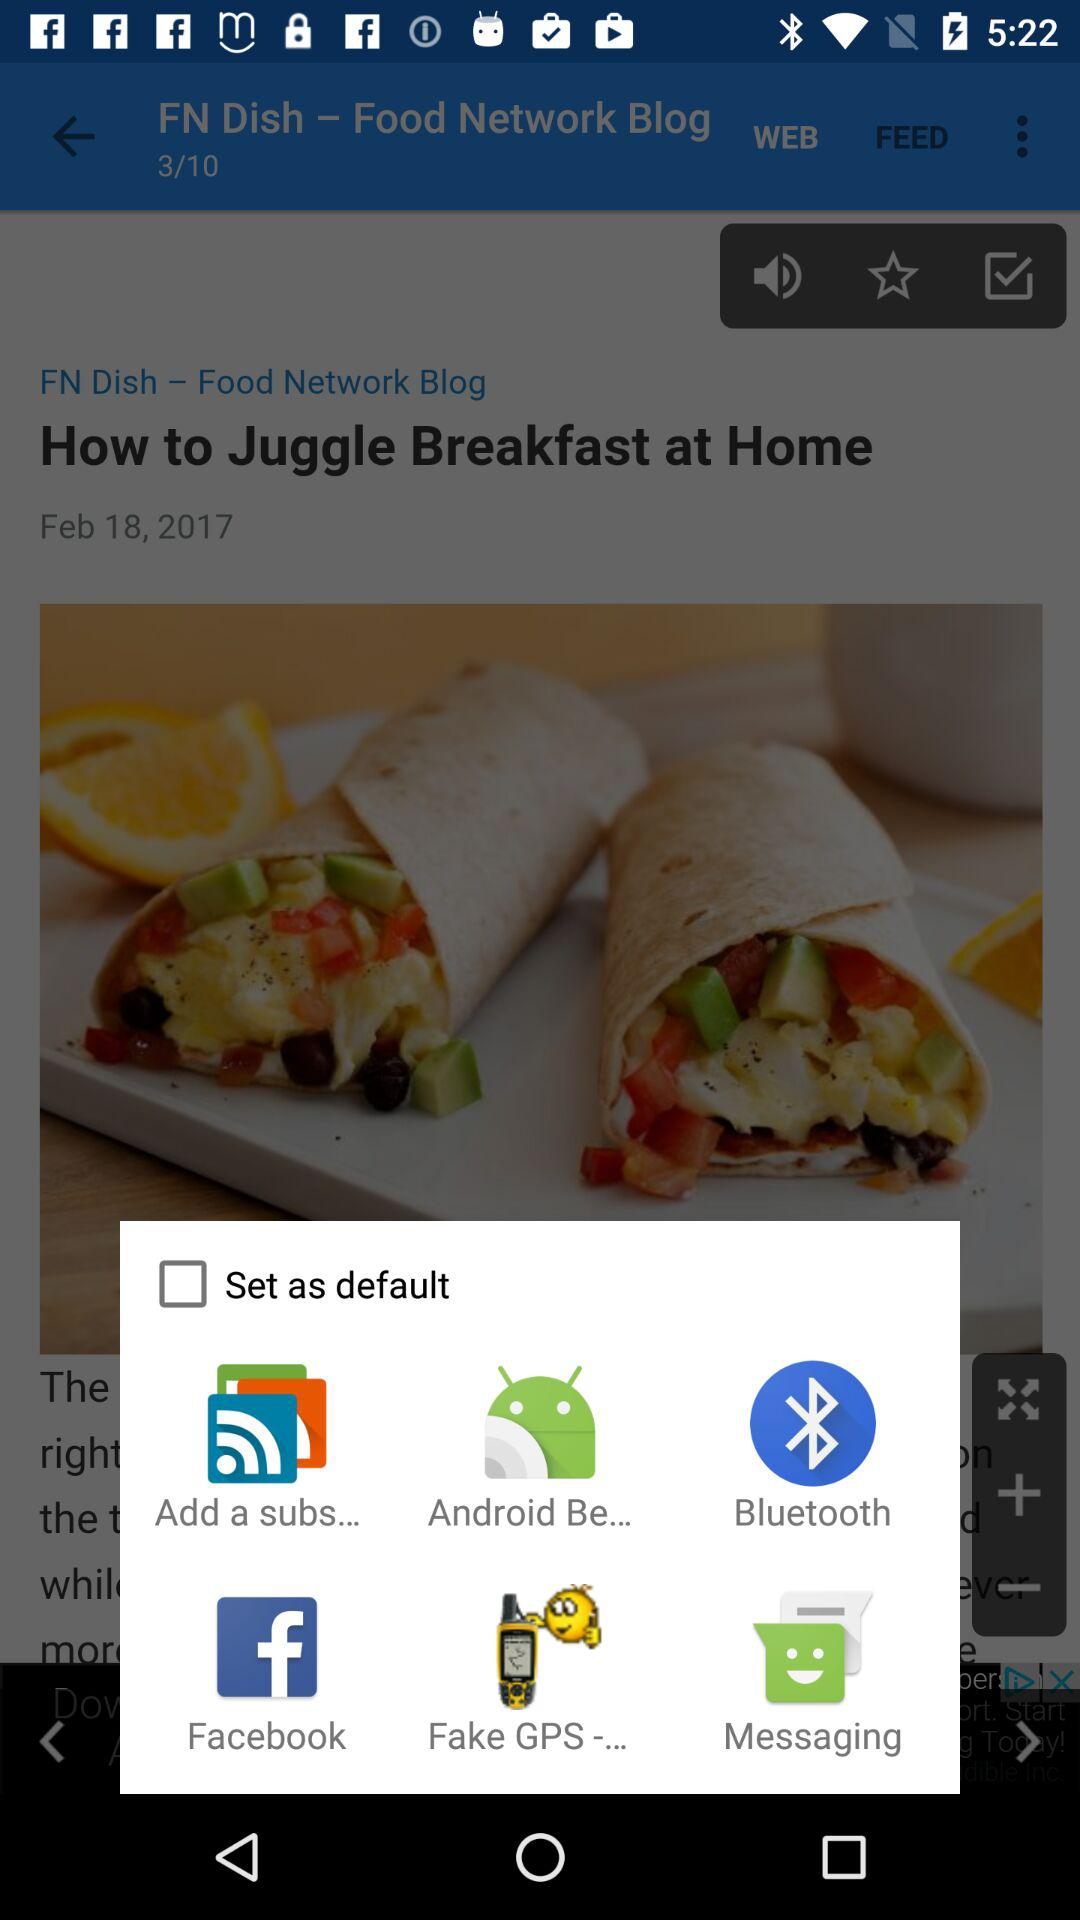What are the different applications to set as default? The different applications to set as default are "Add a subs...", "Android Be...", "Bluetooth", "Facebook", "Fake GPS -..." and "Messaging". 